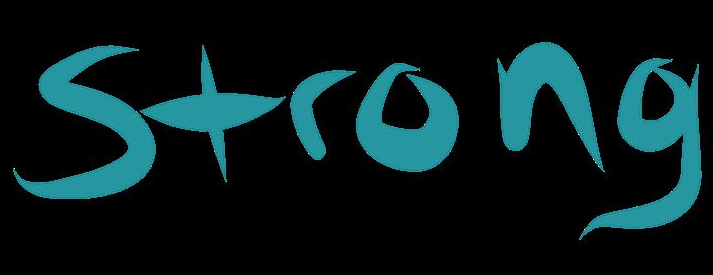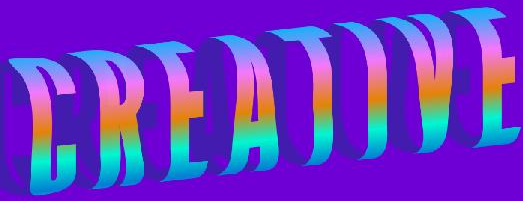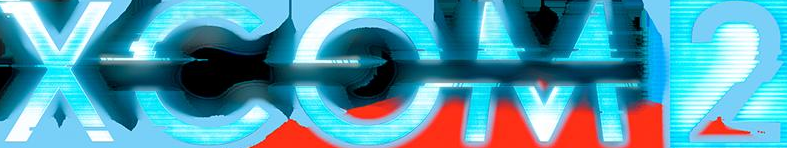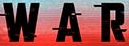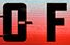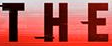Identify the words shown in these images in order, separated by a semicolon. Strong; CREATIVE; XCOM2; WAR; OF; THE 